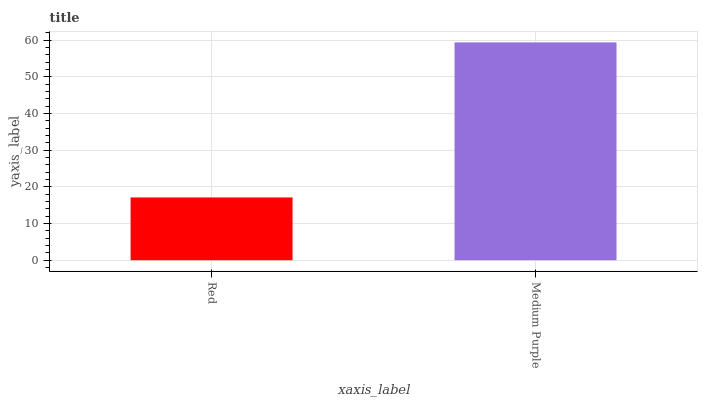Is Medium Purple the minimum?
Answer yes or no. No. Is Medium Purple greater than Red?
Answer yes or no. Yes. Is Red less than Medium Purple?
Answer yes or no. Yes. Is Red greater than Medium Purple?
Answer yes or no. No. Is Medium Purple less than Red?
Answer yes or no. No. Is Medium Purple the high median?
Answer yes or no. Yes. Is Red the low median?
Answer yes or no. Yes. Is Red the high median?
Answer yes or no. No. Is Medium Purple the low median?
Answer yes or no. No. 